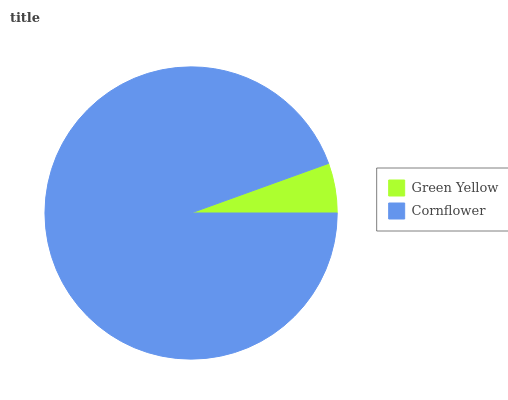Is Green Yellow the minimum?
Answer yes or no. Yes. Is Cornflower the maximum?
Answer yes or no. Yes. Is Cornflower the minimum?
Answer yes or no. No. Is Cornflower greater than Green Yellow?
Answer yes or no. Yes. Is Green Yellow less than Cornflower?
Answer yes or no. Yes. Is Green Yellow greater than Cornflower?
Answer yes or no. No. Is Cornflower less than Green Yellow?
Answer yes or no. No. Is Cornflower the high median?
Answer yes or no. Yes. Is Green Yellow the low median?
Answer yes or no. Yes. Is Green Yellow the high median?
Answer yes or no. No. Is Cornflower the low median?
Answer yes or no. No. 